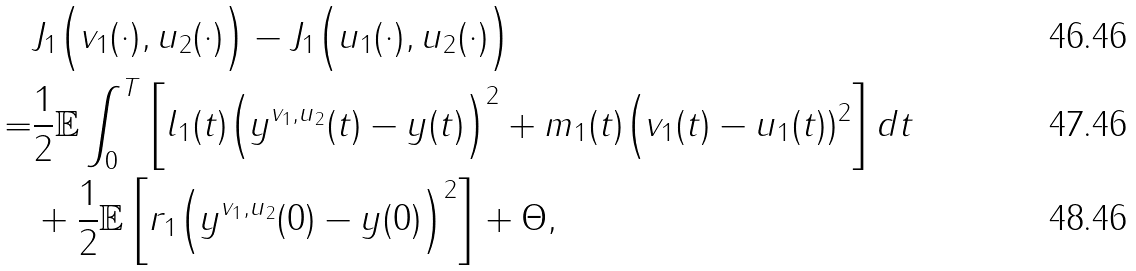Convert formula to latex. <formula><loc_0><loc_0><loc_500><loc_500>& J _ { 1 } \Big ( v _ { 1 } ( \cdot ) , u _ { 2 } ( \cdot ) \Big ) - J _ { 1 } \Big ( u _ { 1 } ( \cdot ) , u _ { 2 } ( \cdot ) \Big ) \\ = & \frac { 1 } { 2 } \mathbb { E } \int _ { 0 } ^ { T } \left [ l _ { 1 } ( t ) \Big ( y ^ { v _ { 1 } , u _ { 2 } } ( t ) - y ( t ) \Big ) ^ { 2 } + m _ { 1 } ( t ) \Big ( v _ { 1 } ( t ) - u _ { 1 } ( t ) ) ^ { 2 } \right ] d t \\ & + \frac { 1 } { 2 } \mathbb { E } \left [ r _ { 1 } \Big ( y ^ { v _ { 1 } , u _ { 2 } } ( 0 ) - y ( 0 ) \Big ) ^ { 2 } \right ] + \Theta ,</formula> 